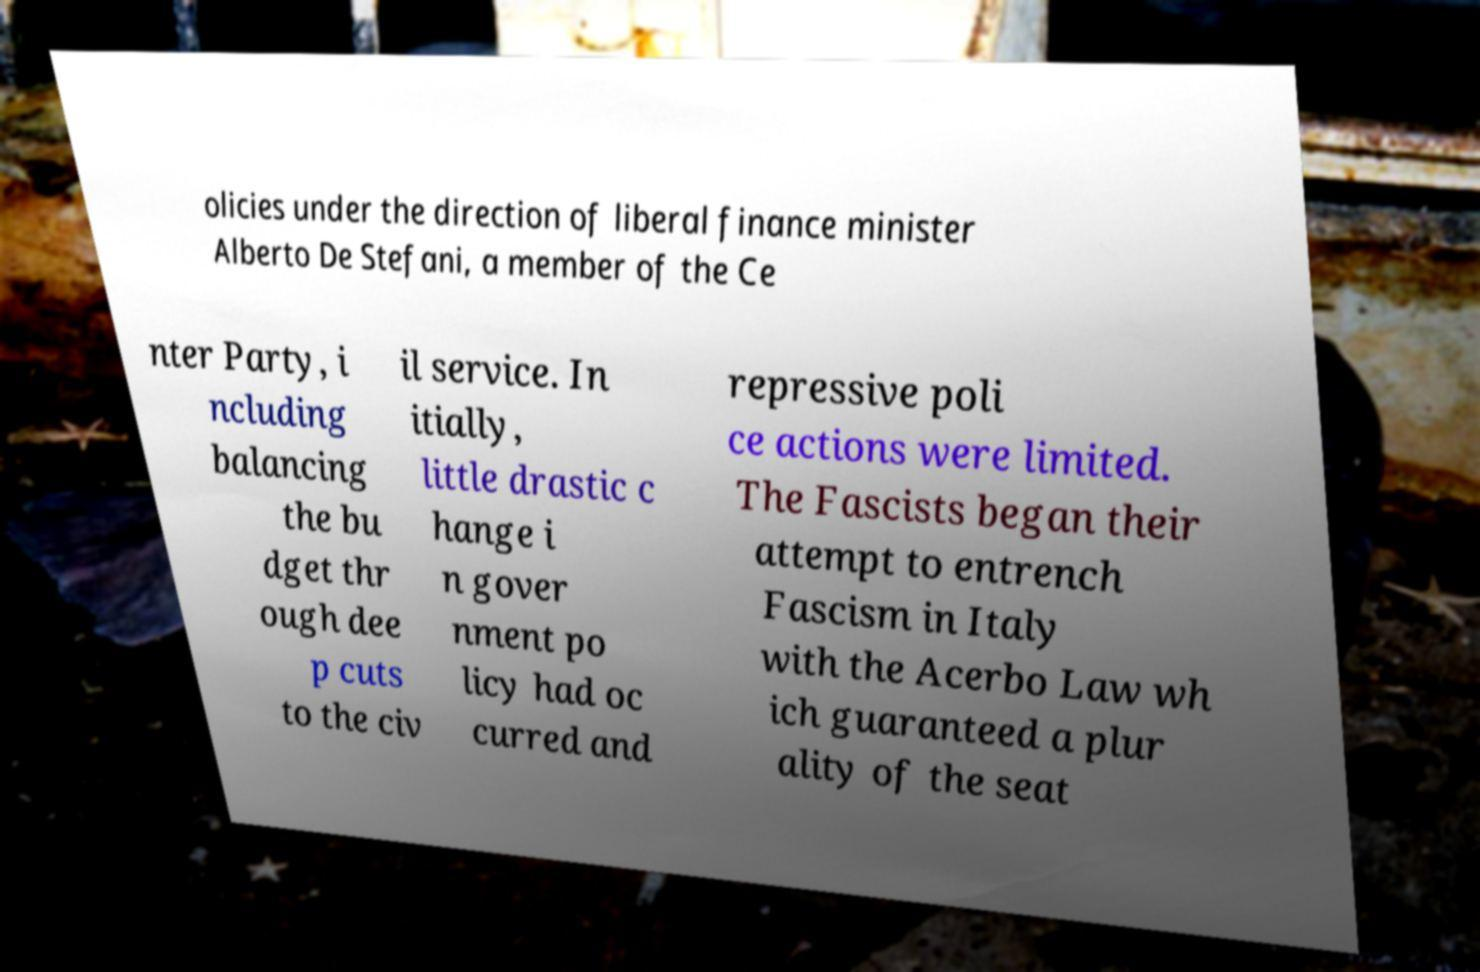I need the written content from this picture converted into text. Can you do that? olicies under the direction of liberal finance minister Alberto De Stefani, a member of the Ce nter Party, i ncluding balancing the bu dget thr ough dee p cuts to the civ il service. In itially, little drastic c hange i n gover nment po licy had oc curred and repressive poli ce actions were limited. The Fascists began their attempt to entrench Fascism in Italy with the Acerbo Law wh ich guaranteed a plur ality of the seat 